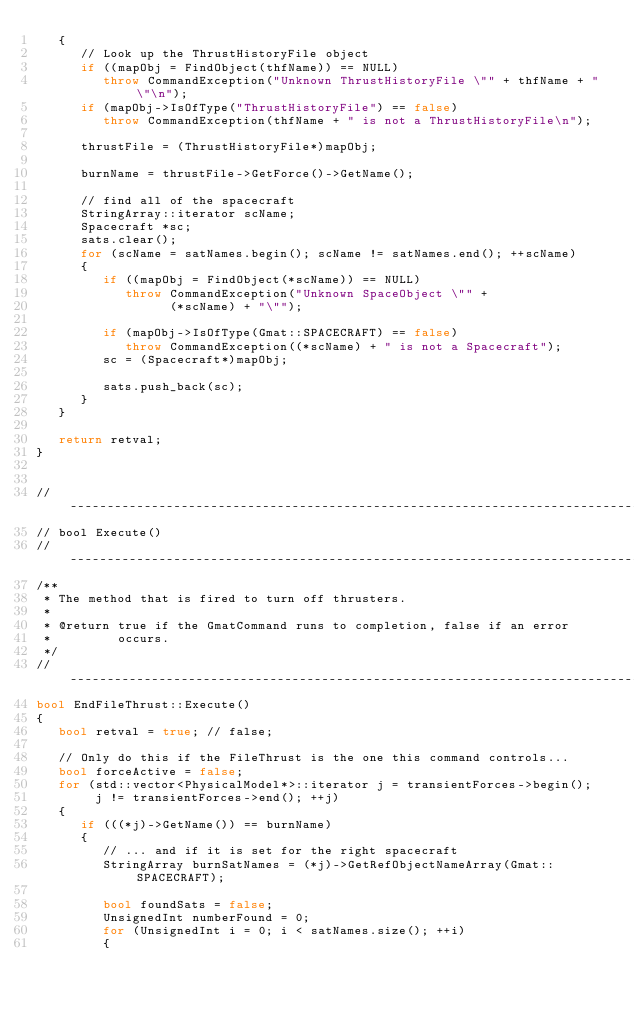<code> <loc_0><loc_0><loc_500><loc_500><_C++_>   {
      // Look up the ThrustHistoryFile object
      if ((mapObj = FindObject(thfName)) == NULL)
         throw CommandException("Unknown ThrustHistoryFile \"" + thfName + "\"\n");
      if (mapObj->IsOfType("ThrustHistoryFile") == false)
         throw CommandException(thfName + " is not a ThrustHistoryFile\n");

      thrustFile = (ThrustHistoryFile*)mapObj;

      burnName = thrustFile->GetForce()->GetName();

      // find all of the spacecraft
      StringArray::iterator scName;
      Spacecraft *sc;
      sats.clear();
      for (scName = satNames.begin(); scName != satNames.end(); ++scName)
      {
         if ((mapObj = FindObject(*scName)) == NULL)
            throw CommandException("Unknown SpaceObject \"" +
                  (*scName) + "\"");

         if (mapObj->IsOfType(Gmat::SPACECRAFT) == false)
            throw CommandException((*scName) + " is not a Spacecraft");
         sc = (Spacecraft*)mapObj;

         sats.push_back(sc);
      }
   }

   return retval;
}


//------------------------------------------------------------------------------
// bool Execute()
//------------------------------------------------------------------------------
/**
 * The method that is fired to turn off thrusters.
 *
 * @return true if the GmatCommand runs to completion, false if an error
 *         occurs.
 */
//------------------------------------------------------------------------------
bool EndFileThrust::Execute()
{
   bool retval = true; // false;

   // Only do this if the FileThrust is the one this command controls...
   bool forceActive = false;
   for (std::vector<PhysicalModel*>::iterator j = transientForces->begin();
        j != transientForces->end(); ++j)
   {
      if (((*j)->GetName()) == burnName)
      {
         // ... and if it is set for the right spacecraft
         StringArray burnSatNames = (*j)->GetRefObjectNameArray(Gmat::SPACECRAFT);

         bool foundSats = false;
         UnsignedInt numberFound = 0;
         for (UnsignedInt i = 0; i < satNames.size(); ++i)
         {</code> 